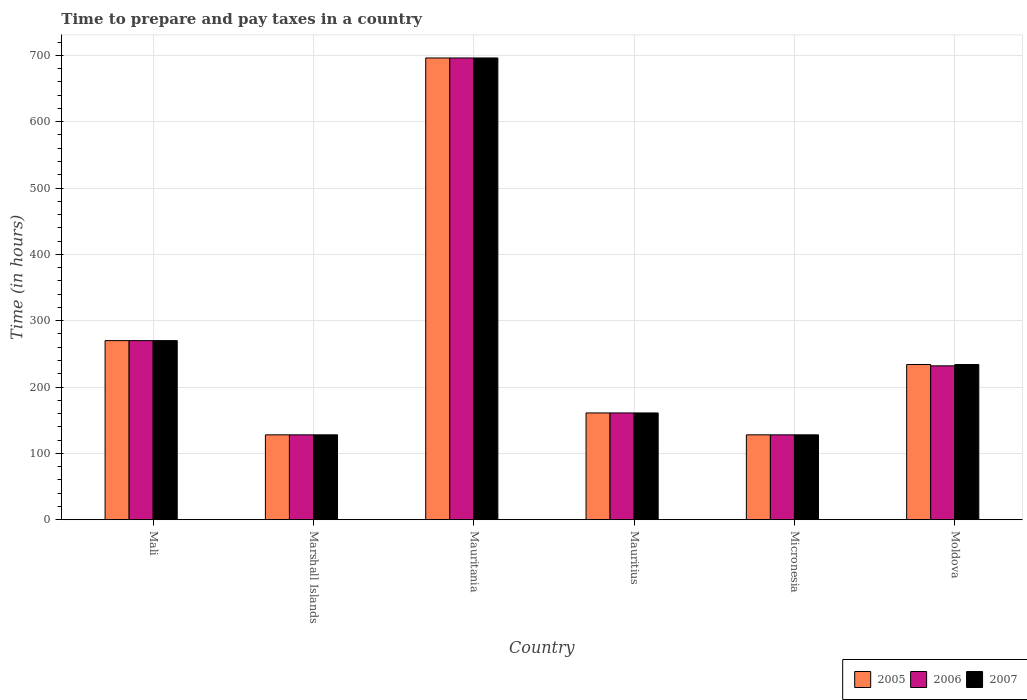How many groups of bars are there?
Offer a terse response. 6. Are the number of bars per tick equal to the number of legend labels?
Make the answer very short. Yes. Are the number of bars on each tick of the X-axis equal?
Provide a short and direct response. Yes. How many bars are there on the 1st tick from the left?
Your answer should be very brief. 3. What is the label of the 6th group of bars from the left?
Your response must be concise. Moldova. What is the number of hours required to prepare and pay taxes in 2007 in Micronesia?
Your answer should be very brief. 128. Across all countries, what is the maximum number of hours required to prepare and pay taxes in 2005?
Your answer should be very brief. 696. Across all countries, what is the minimum number of hours required to prepare and pay taxes in 2007?
Your response must be concise. 128. In which country was the number of hours required to prepare and pay taxes in 2005 maximum?
Offer a terse response. Mauritania. In which country was the number of hours required to prepare and pay taxes in 2005 minimum?
Your answer should be compact. Marshall Islands. What is the total number of hours required to prepare and pay taxes in 2005 in the graph?
Your answer should be very brief. 1617. What is the difference between the number of hours required to prepare and pay taxes in 2007 in Mali and that in Mauritania?
Make the answer very short. -426. What is the difference between the number of hours required to prepare and pay taxes in 2007 in Moldova and the number of hours required to prepare and pay taxes in 2006 in Mauritius?
Give a very brief answer. 73. What is the average number of hours required to prepare and pay taxes in 2005 per country?
Provide a succinct answer. 269.5. What is the difference between the number of hours required to prepare and pay taxes of/in 2005 and number of hours required to prepare and pay taxes of/in 2006 in Mauritania?
Your response must be concise. 0. What is the ratio of the number of hours required to prepare and pay taxes in 2006 in Micronesia to that in Moldova?
Make the answer very short. 0.55. Is the number of hours required to prepare and pay taxes in 2006 in Mauritania less than that in Mauritius?
Give a very brief answer. No. Is the difference between the number of hours required to prepare and pay taxes in 2005 in Marshall Islands and Moldova greater than the difference between the number of hours required to prepare and pay taxes in 2006 in Marshall Islands and Moldova?
Offer a very short reply. No. What is the difference between the highest and the second highest number of hours required to prepare and pay taxes in 2007?
Your answer should be compact. 462. What is the difference between the highest and the lowest number of hours required to prepare and pay taxes in 2006?
Your answer should be compact. 568. In how many countries, is the number of hours required to prepare and pay taxes in 2007 greater than the average number of hours required to prepare and pay taxes in 2007 taken over all countries?
Your answer should be very brief. 2. Is the sum of the number of hours required to prepare and pay taxes in 2007 in Micronesia and Moldova greater than the maximum number of hours required to prepare and pay taxes in 2005 across all countries?
Your response must be concise. No. Is it the case that in every country, the sum of the number of hours required to prepare and pay taxes in 2005 and number of hours required to prepare and pay taxes in 2006 is greater than the number of hours required to prepare and pay taxes in 2007?
Make the answer very short. Yes. How many bars are there?
Ensure brevity in your answer.  18. Are all the bars in the graph horizontal?
Provide a short and direct response. No. How many countries are there in the graph?
Provide a short and direct response. 6. What is the difference between two consecutive major ticks on the Y-axis?
Your answer should be very brief. 100. Are the values on the major ticks of Y-axis written in scientific E-notation?
Provide a short and direct response. No. Does the graph contain any zero values?
Offer a very short reply. No. Where does the legend appear in the graph?
Give a very brief answer. Bottom right. How are the legend labels stacked?
Offer a terse response. Horizontal. What is the title of the graph?
Provide a succinct answer. Time to prepare and pay taxes in a country. Does "1984" appear as one of the legend labels in the graph?
Your answer should be very brief. No. What is the label or title of the Y-axis?
Offer a terse response. Time (in hours). What is the Time (in hours) in 2005 in Mali?
Your response must be concise. 270. What is the Time (in hours) of 2006 in Mali?
Your answer should be compact. 270. What is the Time (in hours) of 2007 in Mali?
Offer a terse response. 270. What is the Time (in hours) of 2005 in Marshall Islands?
Keep it short and to the point. 128. What is the Time (in hours) in 2006 in Marshall Islands?
Offer a terse response. 128. What is the Time (in hours) of 2007 in Marshall Islands?
Provide a short and direct response. 128. What is the Time (in hours) of 2005 in Mauritania?
Offer a terse response. 696. What is the Time (in hours) of 2006 in Mauritania?
Offer a terse response. 696. What is the Time (in hours) in 2007 in Mauritania?
Your answer should be compact. 696. What is the Time (in hours) in 2005 in Mauritius?
Your answer should be very brief. 161. What is the Time (in hours) in 2006 in Mauritius?
Offer a very short reply. 161. What is the Time (in hours) in 2007 in Mauritius?
Your answer should be very brief. 161. What is the Time (in hours) of 2005 in Micronesia?
Offer a very short reply. 128. What is the Time (in hours) of 2006 in Micronesia?
Your answer should be compact. 128. What is the Time (in hours) in 2007 in Micronesia?
Keep it short and to the point. 128. What is the Time (in hours) in 2005 in Moldova?
Your answer should be very brief. 234. What is the Time (in hours) of 2006 in Moldova?
Your response must be concise. 232. What is the Time (in hours) in 2007 in Moldova?
Provide a succinct answer. 234. Across all countries, what is the maximum Time (in hours) in 2005?
Give a very brief answer. 696. Across all countries, what is the maximum Time (in hours) of 2006?
Keep it short and to the point. 696. Across all countries, what is the maximum Time (in hours) in 2007?
Ensure brevity in your answer.  696. Across all countries, what is the minimum Time (in hours) in 2005?
Offer a very short reply. 128. Across all countries, what is the minimum Time (in hours) of 2006?
Your answer should be very brief. 128. Across all countries, what is the minimum Time (in hours) of 2007?
Keep it short and to the point. 128. What is the total Time (in hours) in 2005 in the graph?
Provide a short and direct response. 1617. What is the total Time (in hours) of 2006 in the graph?
Offer a terse response. 1615. What is the total Time (in hours) of 2007 in the graph?
Keep it short and to the point. 1617. What is the difference between the Time (in hours) in 2005 in Mali and that in Marshall Islands?
Make the answer very short. 142. What is the difference between the Time (in hours) in 2006 in Mali and that in Marshall Islands?
Your response must be concise. 142. What is the difference between the Time (in hours) of 2007 in Mali and that in Marshall Islands?
Offer a very short reply. 142. What is the difference between the Time (in hours) in 2005 in Mali and that in Mauritania?
Your answer should be compact. -426. What is the difference between the Time (in hours) in 2006 in Mali and that in Mauritania?
Your answer should be compact. -426. What is the difference between the Time (in hours) in 2007 in Mali and that in Mauritania?
Provide a short and direct response. -426. What is the difference between the Time (in hours) in 2005 in Mali and that in Mauritius?
Your response must be concise. 109. What is the difference between the Time (in hours) in 2006 in Mali and that in Mauritius?
Your response must be concise. 109. What is the difference between the Time (in hours) of 2007 in Mali and that in Mauritius?
Your answer should be very brief. 109. What is the difference between the Time (in hours) in 2005 in Mali and that in Micronesia?
Your answer should be compact. 142. What is the difference between the Time (in hours) in 2006 in Mali and that in Micronesia?
Provide a short and direct response. 142. What is the difference between the Time (in hours) of 2007 in Mali and that in Micronesia?
Make the answer very short. 142. What is the difference between the Time (in hours) of 2006 in Mali and that in Moldova?
Make the answer very short. 38. What is the difference between the Time (in hours) in 2005 in Marshall Islands and that in Mauritania?
Provide a succinct answer. -568. What is the difference between the Time (in hours) of 2006 in Marshall Islands and that in Mauritania?
Offer a terse response. -568. What is the difference between the Time (in hours) of 2007 in Marshall Islands and that in Mauritania?
Offer a very short reply. -568. What is the difference between the Time (in hours) in 2005 in Marshall Islands and that in Mauritius?
Provide a short and direct response. -33. What is the difference between the Time (in hours) of 2006 in Marshall Islands and that in Mauritius?
Your answer should be very brief. -33. What is the difference between the Time (in hours) in 2007 in Marshall Islands and that in Mauritius?
Offer a terse response. -33. What is the difference between the Time (in hours) of 2005 in Marshall Islands and that in Micronesia?
Offer a terse response. 0. What is the difference between the Time (in hours) of 2005 in Marshall Islands and that in Moldova?
Your answer should be compact. -106. What is the difference between the Time (in hours) of 2006 in Marshall Islands and that in Moldova?
Your answer should be compact. -104. What is the difference between the Time (in hours) in 2007 in Marshall Islands and that in Moldova?
Your response must be concise. -106. What is the difference between the Time (in hours) in 2005 in Mauritania and that in Mauritius?
Give a very brief answer. 535. What is the difference between the Time (in hours) of 2006 in Mauritania and that in Mauritius?
Provide a succinct answer. 535. What is the difference between the Time (in hours) in 2007 in Mauritania and that in Mauritius?
Your answer should be very brief. 535. What is the difference between the Time (in hours) in 2005 in Mauritania and that in Micronesia?
Keep it short and to the point. 568. What is the difference between the Time (in hours) of 2006 in Mauritania and that in Micronesia?
Offer a very short reply. 568. What is the difference between the Time (in hours) of 2007 in Mauritania and that in Micronesia?
Ensure brevity in your answer.  568. What is the difference between the Time (in hours) of 2005 in Mauritania and that in Moldova?
Provide a succinct answer. 462. What is the difference between the Time (in hours) in 2006 in Mauritania and that in Moldova?
Keep it short and to the point. 464. What is the difference between the Time (in hours) of 2007 in Mauritania and that in Moldova?
Keep it short and to the point. 462. What is the difference between the Time (in hours) of 2007 in Mauritius and that in Micronesia?
Make the answer very short. 33. What is the difference between the Time (in hours) of 2005 in Mauritius and that in Moldova?
Provide a short and direct response. -73. What is the difference between the Time (in hours) in 2006 in Mauritius and that in Moldova?
Your answer should be very brief. -71. What is the difference between the Time (in hours) of 2007 in Mauritius and that in Moldova?
Offer a very short reply. -73. What is the difference between the Time (in hours) in 2005 in Micronesia and that in Moldova?
Give a very brief answer. -106. What is the difference between the Time (in hours) in 2006 in Micronesia and that in Moldova?
Give a very brief answer. -104. What is the difference between the Time (in hours) of 2007 in Micronesia and that in Moldova?
Your answer should be very brief. -106. What is the difference between the Time (in hours) of 2005 in Mali and the Time (in hours) of 2006 in Marshall Islands?
Your answer should be compact. 142. What is the difference between the Time (in hours) of 2005 in Mali and the Time (in hours) of 2007 in Marshall Islands?
Give a very brief answer. 142. What is the difference between the Time (in hours) in 2006 in Mali and the Time (in hours) in 2007 in Marshall Islands?
Make the answer very short. 142. What is the difference between the Time (in hours) of 2005 in Mali and the Time (in hours) of 2006 in Mauritania?
Provide a short and direct response. -426. What is the difference between the Time (in hours) in 2005 in Mali and the Time (in hours) in 2007 in Mauritania?
Provide a short and direct response. -426. What is the difference between the Time (in hours) in 2006 in Mali and the Time (in hours) in 2007 in Mauritania?
Give a very brief answer. -426. What is the difference between the Time (in hours) of 2005 in Mali and the Time (in hours) of 2006 in Mauritius?
Offer a terse response. 109. What is the difference between the Time (in hours) of 2005 in Mali and the Time (in hours) of 2007 in Mauritius?
Keep it short and to the point. 109. What is the difference between the Time (in hours) in 2006 in Mali and the Time (in hours) in 2007 in Mauritius?
Your response must be concise. 109. What is the difference between the Time (in hours) in 2005 in Mali and the Time (in hours) in 2006 in Micronesia?
Your answer should be compact. 142. What is the difference between the Time (in hours) of 2005 in Mali and the Time (in hours) of 2007 in Micronesia?
Your answer should be very brief. 142. What is the difference between the Time (in hours) in 2006 in Mali and the Time (in hours) in 2007 in Micronesia?
Offer a very short reply. 142. What is the difference between the Time (in hours) in 2005 in Mali and the Time (in hours) in 2006 in Moldova?
Provide a succinct answer. 38. What is the difference between the Time (in hours) in 2005 in Mali and the Time (in hours) in 2007 in Moldova?
Your answer should be very brief. 36. What is the difference between the Time (in hours) of 2005 in Marshall Islands and the Time (in hours) of 2006 in Mauritania?
Your response must be concise. -568. What is the difference between the Time (in hours) in 2005 in Marshall Islands and the Time (in hours) in 2007 in Mauritania?
Offer a very short reply. -568. What is the difference between the Time (in hours) of 2006 in Marshall Islands and the Time (in hours) of 2007 in Mauritania?
Your answer should be compact. -568. What is the difference between the Time (in hours) in 2005 in Marshall Islands and the Time (in hours) in 2006 in Mauritius?
Ensure brevity in your answer.  -33. What is the difference between the Time (in hours) in 2005 in Marshall Islands and the Time (in hours) in 2007 in Mauritius?
Provide a succinct answer. -33. What is the difference between the Time (in hours) in 2006 in Marshall Islands and the Time (in hours) in 2007 in Mauritius?
Offer a terse response. -33. What is the difference between the Time (in hours) of 2005 in Marshall Islands and the Time (in hours) of 2006 in Micronesia?
Ensure brevity in your answer.  0. What is the difference between the Time (in hours) of 2005 in Marshall Islands and the Time (in hours) of 2007 in Micronesia?
Make the answer very short. 0. What is the difference between the Time (in hours) of 2006 in Marshall Islands and the Time (in hours) of 2007 in Micronesia?
Your response must be concise. 0. What is the difference between the Time (in hours) in 2005 in Marshall Islands and the Time (in hours) in 2006 in Moldova?
Your answer should be very brief. -104. What is the difference between the Time (in hours) of 2005 in Marshall Islands and the Time (in hours) of 2007 in Moldova?
Your answer should be compact. -106. What is the difference between the Time (in hours) in 2006 in Marshall Islands and the Time (in hours) in 2007 in Moldova?
Provide a succinct answer. -106. What is the difference between the Time (in hours) in 2005 in Mauritania and the Time (in hours) in 2006 in Mauritius?
Give a very brief answer. 535. What is the difference between the Time (in hours) in 2005 in Mauritania and the Time (in hours) in 2007 in Mauritius?
Keep it short and to the point. 535. What is the difference between the Time (in hours) of 2006 in Mauritania and the Time (in hours) of 2007 in Mauritius?
Your response must be concise. 535. What is the difference between the Time (in hours) of 2005 in Mauritania and the Time (in hours) of 2006 in Micronesia?
Offer a very short reply. 568. What is the difference between the Time (in hours) in 2005 in Mauritania and the Time (in hours) in 2007 in Micronesia?
Offer a terse response. 568. What is the difference between the Time (in hours) in 2006 in Mauritania and the Time (in hours) in 2007 in Micronesia?
Your response must be concise. 568. What is the difference between the Time (in hours) in 2005 in Mauritania and the Time (in hours) in 2006 in Moldova?
Your answer should be very brief. 464. What is the difference between the Time (in hours) of 2005 in Mauritania and the Time (in hours) of 2007 in Moldova?
Provide a short and direct response. 462. What is the difference between the Time (in hours) in 2006 in Mauritania and the Time (in hours) in 2007 in Moldova?
Provide a short and direct response. 462. What is the difference between the Time (in hours) in 2005 in Mauritius and the Time (in hours) in 2006 in Micronesia?
Offer a terse response. 33. What is the difference between the Time (in hours) of 2005 in Mauritius and the Time (in hours) of 2006 in Moldova?
Offer a terse response. -71. What is the difference between the Time (in hours) of 2005 in Mauritius and the Time (in hours) of 2007 in Moldova?
Your response must be concise. -73. What is the difference between the Time (in hours) of 2006 in Mauritius and the Time (in hours) of 2007 in Moldova?
Ensure brevity in your answer.  -73. What is the difference between the Time (in hours) of 2005 in Micronesia and the Time (in hours) of 2006 in Moldova?
Provide a succinct answer. -104. What is the difference between the Time (in hours) of 2005 in Micronesia and the Time (in hours) of 2007 in Moldova?
Provide a short and direct response. -106. What is the difference between the Time (in hours) of 2006 in Micronesia and the Time (in hours) of 2007 in Moldova?
Offer a very short reply. -106. What is the average Time (in hours) in 2005 per country?
Make the answer very short. 269.5. What is the average Time (in hours) of 2006 per country?
Keep it short and to the point. 269.17. What is the average Time (in hours) of 2007 per country?
Give a very brief answer. 269.5. What is the difference between the Time (in hours) in 2005 and Time (in hours) in 2006 in Mali?
Your answer should be compact. 0. What is the difference between the Time (in hours) of 2005 and Time (in hours) of 2007 in Mali?
Provide a succinct answer. 0. What is the difference between the Time (in hours) in 2006 and Time (in hours) in 2007 in Mali?
Your answer should be very brief. 0. What is the difference between the Time (in hours) of 2005 and Time (in hours) of 2006 in Mauritania?
Ensure brevity in your answer.  0. What is the difference between the Time (in hours) in 2006 and Time (in hours) in 2007 in Mauritania?
Offer a very short reply. 0. What is the difference between the Time (in hours) in 2005 and Time (in hours) in 2006 in Mauritius?
Offer a terse response. 0. What is the difference between the Time (in hours) of 2005 and Time (in hours) of 2007 in Mauritius?
Offer a very short reply. 0. What is the difference between the Time (in hours) of 2005 and Time (in hours) of 2007 in Micronesia?
Offer a terse response. 0. What is the difference between the Time (in hours) in 2005 and Time (in hours) in 2006 in Moldova?
Keep it short and to the point. 2. What is the difference between the Time (in hours) in 2006 and Time (in hours) in 2007 in Moldova?
Provide a succinct answer. -2. What is the ratio of the Time (in hours) of 2005 in Mali to that in Marshall Islands?
Your response must be concise. 2.11. What is the ratio of the Time (in hours) in 2006 in Mali to that in Marshall Islands?
Give a very brief answer. 2.11. What is the ratio of the Time (in hours) of 2007 in Mali to that in Marshall Islands?
Your answer should be compact. 2.11. What is the ratio of the Time (in hours) of 2005 in Mali to that in Mauritania?
Give a very brief answer. 0.39. What is the ratio of the Time (in hours) of 2006 in Mali to that in Mauritania?
Offer a very short reply. 0.39. What is the ratio of the Time (in hours) in 2007 in Mali to that in Mauritania?
Provide a short and direct response. 0.39. What is the ratio of the Time (in hours) in 2005 in Mali to that in Mauritius?
Keep it short and to the point. 1.68. What is the ratio of the Time (in hours) of 2006 in Mali to that in Mauritius?
Provide a short and direct response. 1.68. What is the ratio of the Time (in hours) in 2007 in Mali to that in Mauritius?
Make the answer very short. 1.68. What is the ratio of the Time (in hours) in 2005 in Mali to that in Micronesia?
Your response must be concise. 2.11. What is the ratio of the Time (in hours) in 2006 in Mali to that in Micronesia?
Your answer should be very brief. 2.11. What is the ratio of the Time (in hours) in 2007 in Mali to that in Micronesia?
Your answer should be very brief. 2.11. What is the ratio of the Time (in hours) of 2005 in Mali to that in Moldova?
Your response must be concise. 1.15. What is the ratio of the Time (in hours) of 2006 in Mali to that in Moldova?
Make the answer very short. 1.16. What is the ratio of the Time (in hours) of 2007 in Mali to that in Moldova?
Your response must be concise. 1.15. What is the ratio of the Time (in hours) in 2005 in Marshall Islands to that in Mauritania?
Provide a succinct answer. 0.18. What is the ratio of the Time (in hours) of 2006 in Marshall Islands to that in Mauritania?
Provide a succinct answer. 0.18. What is the ratio of the Time (in hours) in 2007 in Marshall Islands to that in Mauritania?
Offer a terse response. 0.18. What is the ratio of the Time (in hours) in 2005 in Marshall Islands to that in Mauritius?
Your answer should be very brief. 0.8. What is the ratio of the Time (in hours) of 2006 in Marshall Islands to that in Mauritius?
Your answer should be compact. 0.8. What is the ratio of the Time (in hours) in 2007 in Marshall Islands to that in Mauritius?
Your answer should be very brief. 0.8. What is the ratio of the Time (in hours) of 2005 in Marshall Islands to that in Micronesia?
Your answer should be compact. 1. What is the ratio of the Time (in hours) of 2007 in Marshall Islands to that in Micronesia?
Make the answer very short. 1. What is the ratio of the Time (in hours) of 2005 in Marshall Islands to that in Moldova?
Your response must be concise. 0.55. What is the ratio of the Time (in hours) in 2006 in Marshall Islands to that in Moldova?
Keep it short and to the point. 0.55. What is the ratio of the Time (in hours) of 2007 in Marshall Islands to that in Moldova?
Make the answer very short. 0.55. What is the ratio of the Time (in hours) of 2005 in Mauritania to that in Mauritius?
Make the answer very short. 4.32. What is the ratio of the Time (in hours) of 2006 in Mauritania to that in Mauritius?
Your answer should be very brief. 4.32. What is the ratio of the Time (in hours) of 2007 in Mauritania to that in Mauritius?
Your answer should be compact. 4.32. What is the ratio of the Time (in hours) in 2005 in Mauritania to that in Micronesia?
Make the answer very short. 5.44. What is the ratio of the Time (in hours) in 2006 in Mauritania to that in Micronesia?
Your response must be concise. 5.44. What is the ratio of the Time (in hours) in 2007 in Mauritania to that in Micronesia?
Ensure brevity in your answer.  5.44. What is the ratio of the Time (in hours) in 2005 in Mauritania to that in Moldova?
Your response must be concise. 2.97. What is the ratio of the Time (in hours) in 2007 in Mauritania to that in Moldova?
Your answer should be compact. 2.97. What is the ratio of the Time (in hours) of 2005 in Mauritius to that in Micronesia?
Provide a succinct answer. 1.26. What is the ratio of the Time (in hours) of 2006 in Mauritius to that in Micronesia?
Keep it short and to the point. 1.26. What is the ratio of the Time (in hours) of 2007 in Mauritius to that in Micronesia?
Offer a terse response. 1.26. What is the ratio of the Time (in hours) in 2005 in Mauritius to that in Moldova?
Your answer should be very brief. 0.69. What is the ratio of the Time (in hours) of 2006 in Mauritius to that in Moldova?
Provide a short and direct response. 0.69. What is the ratio of the Time (in hours) of 2007 in Mauritius to that in Moldova?
Provide a succinct answer. 0.69. What is the ratio of the Time (in hours) of 2005 in Micronesia to that in Moldova?
Keep it short and to the point. 0.55. What is the ratio of the Time (in hours) of 2006 in Micronesia to that in Moldova?
Offer a very short reply. 0.55. What is the ratio of the Time (in hours) of 2007 in Micronesia to that in Moldova?
Keep it short and to the point. 0.55. What is the difference between the highest and the second highest Time (in hours) of 2005?
Provide a succinct answer. 426. What is the difference between the highest and the second highest Time (in hours) of 2006?
Ensure brevity in your answer.  426. What is the difference between the highest and the second highest Time (in hours) of 2007?
Provide a succinct answer. 426. What is the difference between the highest and the lowest Time (in hours) of 2005?
Give a very brief answer. 568. What is the difference between the highest and the lowest Time (in hours) of 2006?
Keep it short and to the point. 568. What is the difference between the highest and the lowest Time (in hours) in 2007?
Your answer should be compact. 568. 